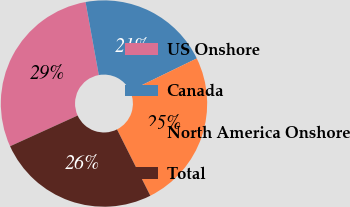Convert chart. <chart><loc_0><loc_0><loc_500><loc_500><pie_chart><fcel>US Onshore<fcel>Canada<fcel>North America Onshore<fcel>Total<nl><fcel>28.93%<fcel>20.66%<fcel>24.79%<fcel>25.62%<nl></chart> 